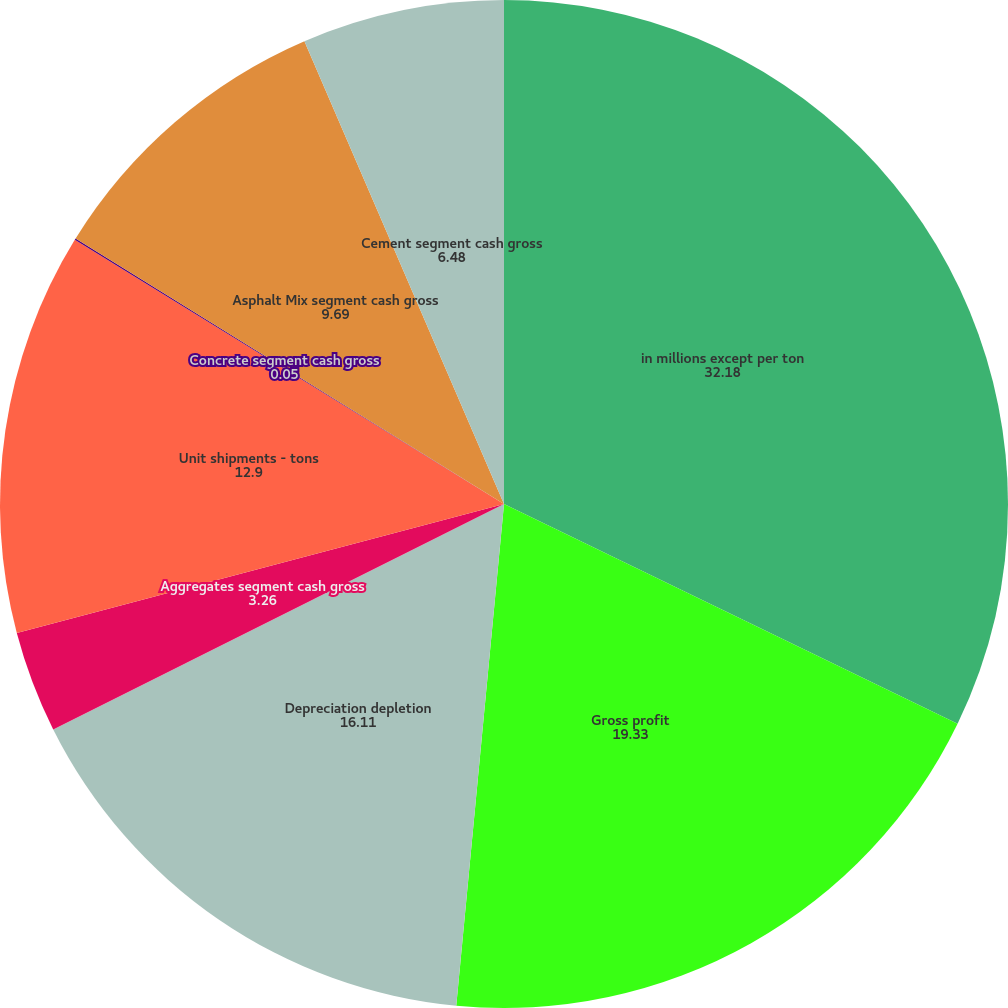Convert chart. <chart><loc_0><loc_0><loc_500><loc_500><pie_chart><fcel>in millions except per ton<fcel>Gross profit<fcel>Depreciation depletion<fcel>Aggregates segment cash gross<fcel>Unit shipments - tons<fcel>Concrete segment cash gross<fcel>Asphalt Mix segment cash gross<fcel>Cement segment cash gross<nl><fcel>32.18%<fcel>19.33%<fcel>16.11%<fcel>3.26%<fcel>12.9%<fcel>0.05%<fcel>9.69%<fcel>6.48%<nl></chart> 